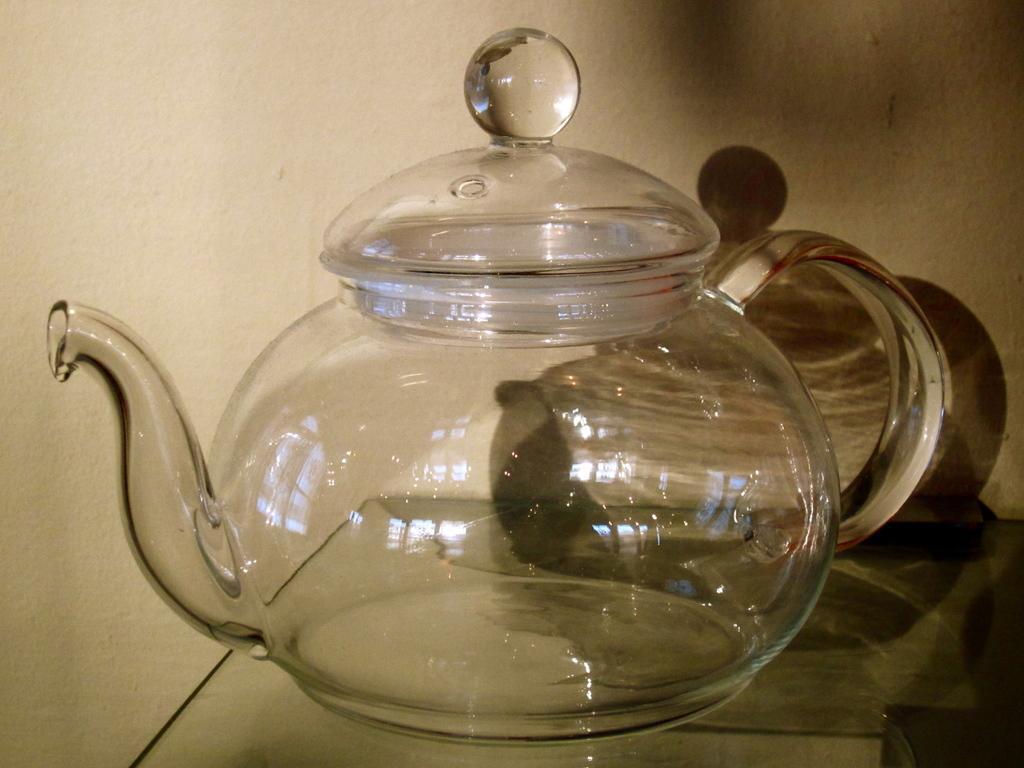How would you summarize this image in a sentence or two? In this picture we can see a teapot in the middle of the image. 